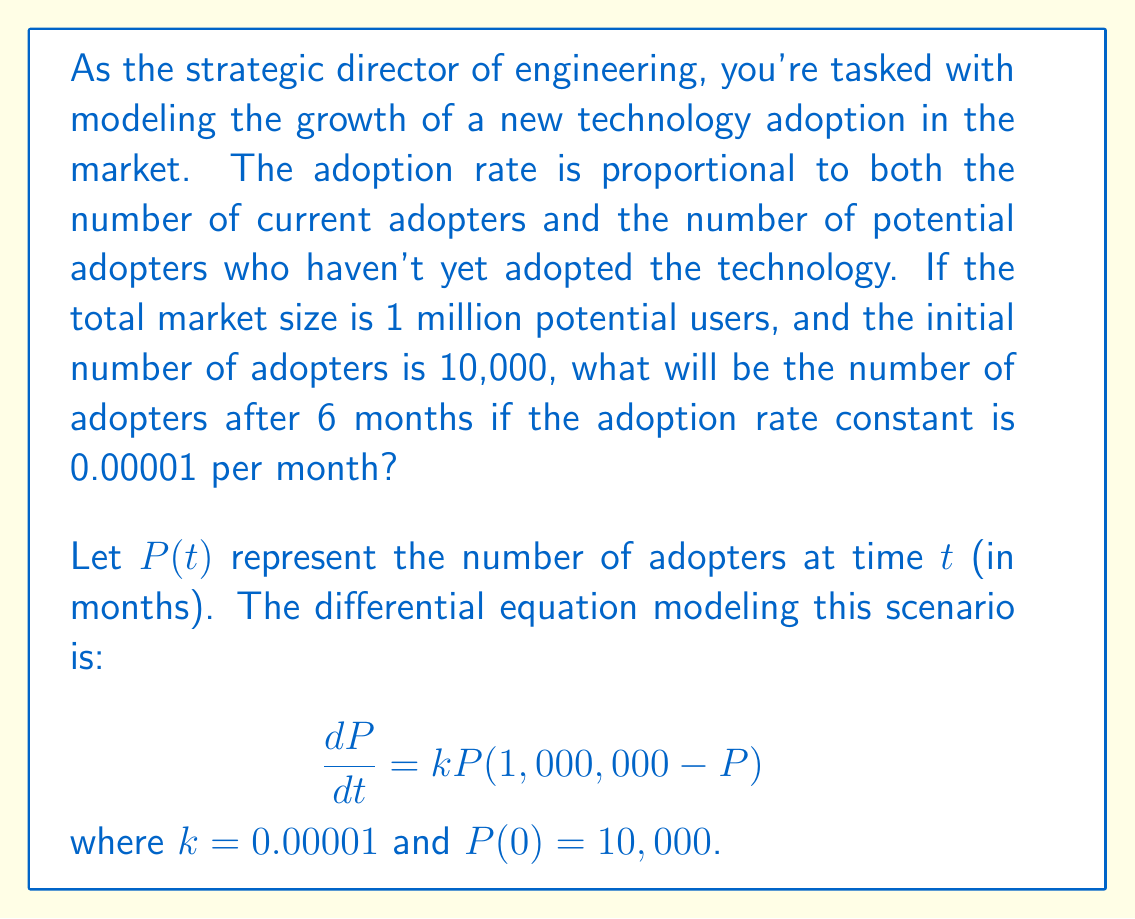Solve this math problem. To solve this problem, we need to use the logistic growth model, which is represented by the given differential equation. Let's solve this step-by-step:

1) The general solution to the logistic equation is:

   $$P(t) = \frac{K}{1 + (\frac{K}{P_0} - 1)e^{-rKt}}$$

   where $K$ is the carrying capacity (total market size), $P_0$ is the initial population, and $r$ is the growth rate.

2) In our case:
   $K = 1,000,000$
   $P_0 = 10,000$
   $r = k = 0.00001$

3) Substituting these values into the equation:

   $$P(t) = \frac{1,000,000}{1 + (\frac{1,000,000}{10,000} - 1)e^{-0.00001 \cdot 1,000,000 \cdot t}}$$

4) Simplify:

   $$P(t) = \frac{1,000,000}{1 + 99e^{-10t}}$$

5) We want to find $P(6)$, so let's substitute $t = 6$:

   $$P(6) = \frac{1,000,000}{1 + 99e^{-60}}$$

6) Calculate this value:
   $e^{-60} \approx 8.756 \times 10^{-27}$
   $99e^{-60} \approx 8.668 \times 10^{-25}$
   
   $$P(6) = \frac{1,000,000}{1 + 8.668 \times 10^{-25}} \approx 999,999.99999999991$$

7) Rounding to the nearest whole number (as we're dealing with people):

   $P(6) \approx 1,000,000$
Answer: 1,000,000 adopters 